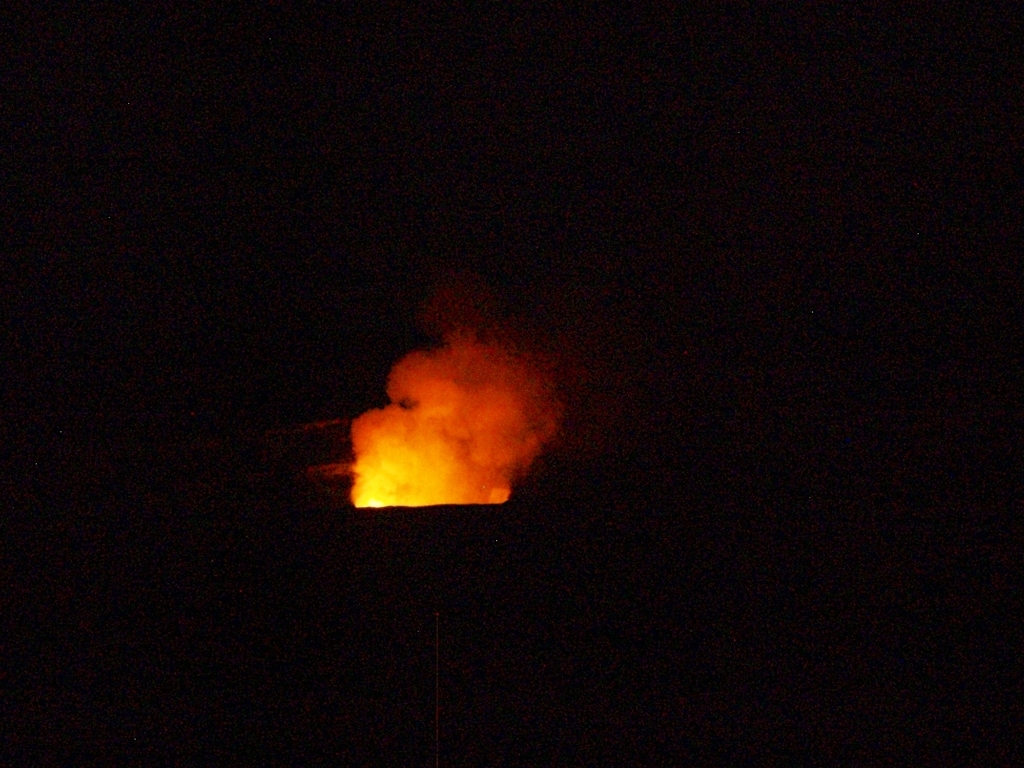How can someone safely photograph an event like this? To safely photograph a fire event, especially at night, one should maintain a safe distance to avoid hazards from heat or smoke. Using a telephoto lens can help capture detailed images from afar. It's also crucial to use manual settings to adjust for low light conditions, using a longer exposure or higher ISO to capture the flames without underexposing the image. 